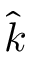Convert formula to latex. <formula><loc_0><loc_0><loc_500><loc_500>\hat { k }</formula> 